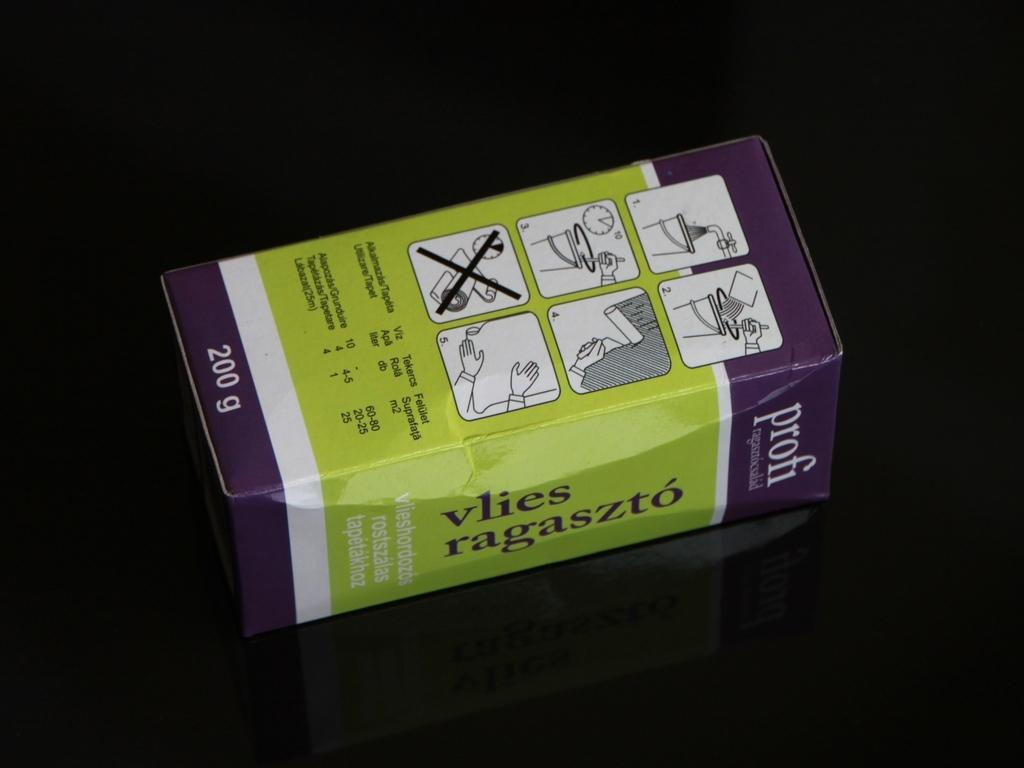<image>
Give a short and clear explanation of the subsequent image. A 200g box of a product that should be mixed with water. 